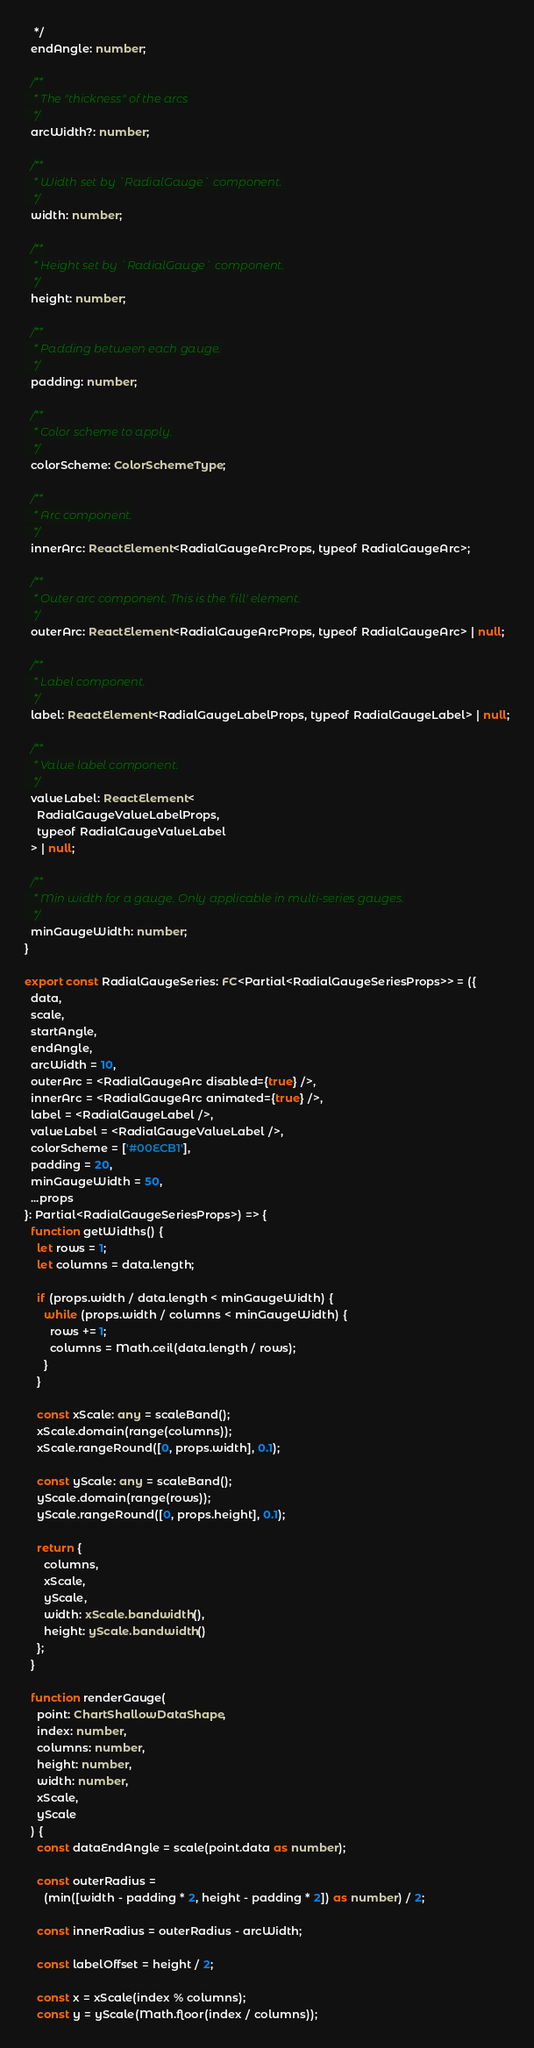<code> <loc_0><loc_0><loc_500><loc_500><_TypeScript_>   */
  endAngle: number;

  /**
   * The "thickness" of the arcs
   */
  arcWidth?: number;

  /**
   * Width set by `RadialGauge` component.
   */
  width: number;

  /**
   * Height set by `RadialGauge` component.
   */
  height: number;

  /**
   * Padding between each gauge.
   */
  padding: number;

  /**
   * Color scheme to apply.
   */
  colorScheme: ColorSchemeType;

  /**
   * Arc component.
   */
  innerArc: ReactElement<RadialGaugeArcProps, typeof RadialGaugeArc>;

  /**
   * Outer arc component. This is the 'fill' element.
   */
  outerArc: ReactElement<RadialGaugeArcProps, typeof RadialGaugeArc> | null;

  /**
   * Label component.
   */
  label: ReactElement<RadialGaugeLabelProps, typeof RadialGaugeLabel> | null;

  /**
   * Value label component.
   */
  valueLabel: ReactElement<
    RadialGaugeValueLabelProps,
    typeof RadialGaugeValueLabel
  > | null;

  /**
   * Min width for a gauge. Only applicable in multi-series gauges.
   */
  minGaugeWidth: number;
}

export const RadialGaugeSeries: FC<Partial<RadialGaugeSeriesProps>> = ({
  data,
  scale,
  startAngle,
  endAngle,
  arcWidth = 10,
  outerArc = <RadialGaugeArc disabled={true} />,
  innerArc = <RadialGaugeArc animated={true} />,
  label = <RadialGaugeLabel />,
  valueLabel = <RadialGaugeValueLabel />,
  colorScheme = ['#00ECB1'],
  padding = 20,
  minGaugeWidth = 50,
  ...props
}: Partial<RadialGaugeSeriesProps>) => {
  function getWidths() {
    let rows = 1;
    let columns = data.length;

    if (props.width / data.length < minGaugeWidth) {
      while (props.width / columns < minGaugeWidth) {
        rows += 1;
        columns = Math.ceil(data.length / rows);
      }
    }

    const xScale: any = scaleBand();
    xScale.domain(range(columns));
    xScale.rangeRound([0, props.width], 0.1);

    const yScale: any = scaleBand();
    yScale.domain(range(rows));
    yScale.rangeRound([0, props.height], 0.1);

    return {
      columns,
      xScale,
      yScale,
      width: xScale.bandwidth(),
      height: yScale.bandwidth()
    };
  }

  function renderGauge(
    point: ChartShallowDataShape,
    index: number,
    columns: number,
    height: number,
    width: number,
    xScale,
    yScale
  ) {
    const dataEndAngle = scale(point.data as number);

    const outerRadius =
      (min([width - padding * 2, height - padding * 2]) as number) / 2;

    const innerRadius = outerRadius - arcWidth;

    const labelOffset = height / 2;

    const x = xScale(index % columns);
    const y = yScale(Math.floor(index / columns));
</code> 